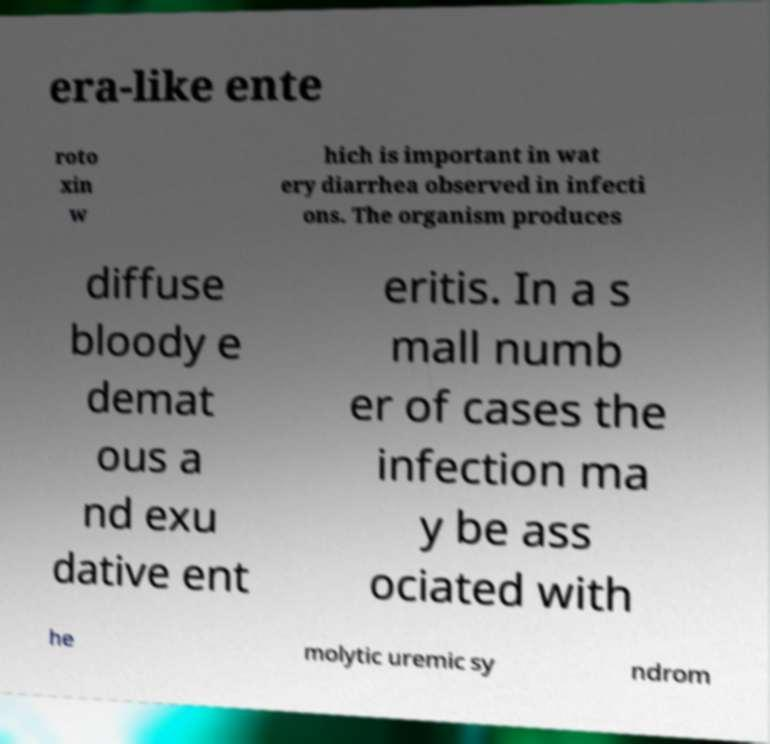Please identify and transcribe the text found in this image. era-like ente roto xin w hich is important in wat ery diarrhea observed in infecti ons. The organism produces diffuse bloody e demat ous a nd exu dative ent eritis. In a s mall numb er of cases the infection ma y be ass ociated with he molytic uremic sy ndrom 